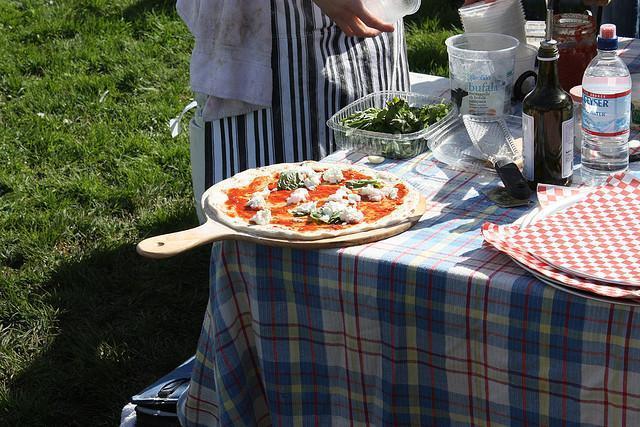How many bottles are there?
Give a very brief answer. 2. How many cups are there?
Give a very brief answer. 2. How many zebras are there?
Give a very brief answer. 0. 